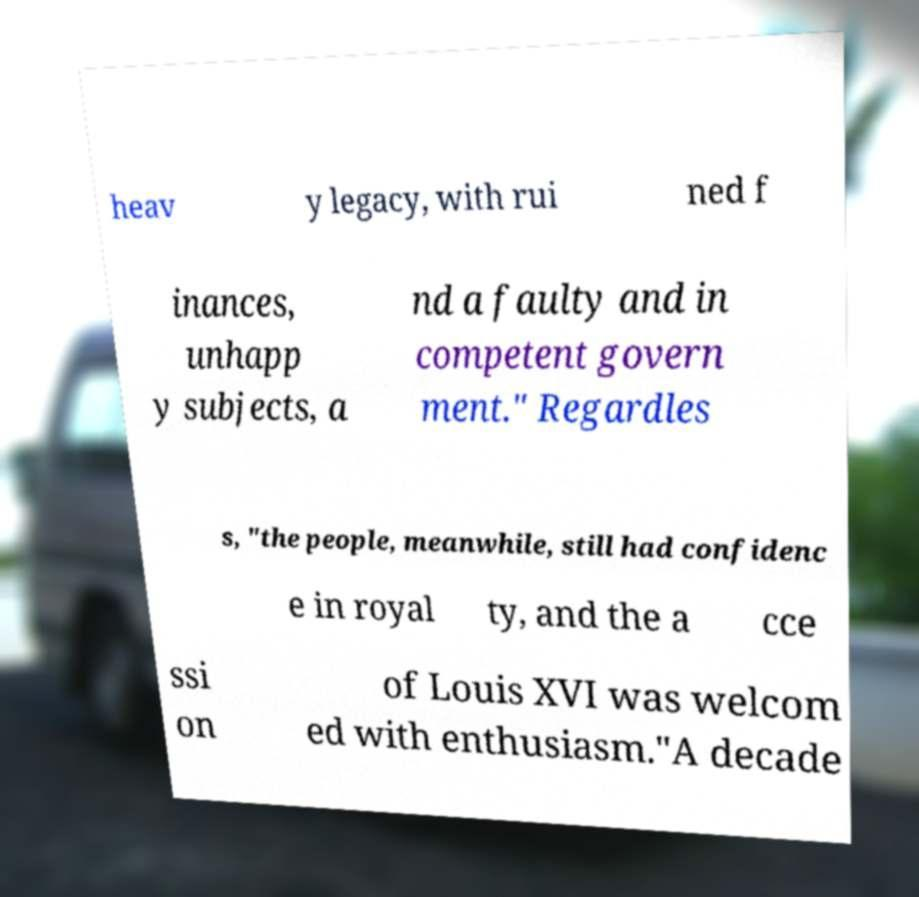I need the written content from this picture converted into text. Can you do that? heav y legacy, with rui ned f inances, unhapp y subjects, a nd a faulty and in competent govern ment." Regardles s, "the people, meanwhile, still had confidenc e in royal ty, and the a cce ssi on of Louis XVI was welcom ed with enthusiasm."A decade 